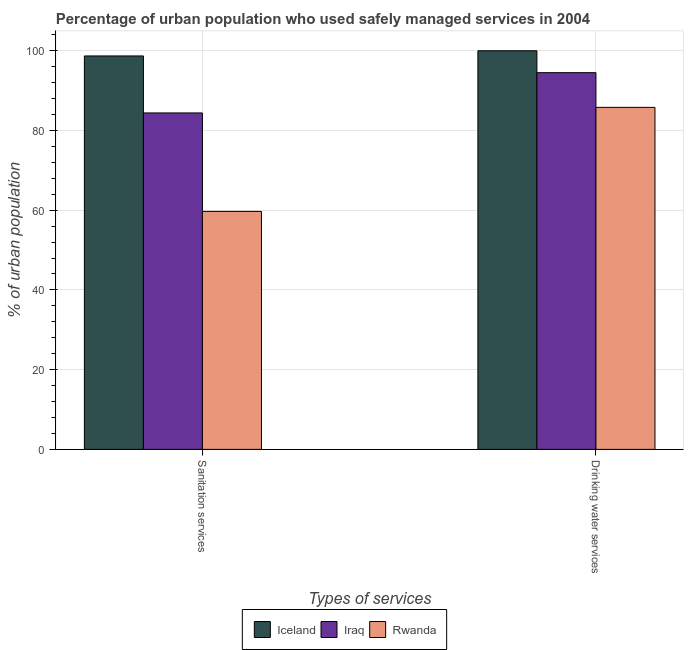How many different coloured bars are there?
Make the answer very short. 3. How many groups of bars are there?
Your response must be concise. 2. Are the number of bars per tick equal to the number of legend labels?
Offer a terse response. Yes. What is the label of the 1st group of bars from the left?
Ensure brevity in your answer.  Sanitation services. What is the percentage of urban population who used sanitation services in Iceland?
Keep it short and to the point. 98.7. Across all countries, what is the maximum percentage of urban population who used sanitation services?
Provide a short and direct response. 98.7. Across all countries, what is the minimum percentage of urban population who used sanitation services?
Offer a very short reply. 59.7. In which country was the percentage of urban population who used drinking water services maximum?
Give a very brief answer. Iceland. In which country was the percentage of urban population who used drinking water services minimum?
Offer a terse response. Rwanda. What is the total percentage of urban population who used sanitation services in the graph?
Offer a very short reply. 242.8. What is the difference between the percentage of urban population who used drinking water services in Iceland and that in Iraq?
Give a very brief answer. 5.5. What is the difference between the percentage of urban population who used sanitation services in Iraq and the percentage of urban population who used drinking water services in Iceland?
Provide a short and direct response. -15.6. What is the average percentage of urban population who used sanitation services per country?
Your response must be concise. 80.93. What is the difference between the percentage of urban population who used sanitation services and percentage of urban population who used drinking water services in Iceland?
Give a very brief answer. -1.3. In how many countries, is the percentage of urban population who used drinking water services greater than 24 %?
Give a very brief answer. 3. What is the ratio of the percentage of urban population who used sanitation services in Iceland to that in Iraq?
Provide a succinct answer. 1.17. Is the percentage of urban population who used sanitation services in Iraq less than that in Rwanda?
Your answer should be compact. No. What does the 2nd bar from the right in Drinking water services represents?
Offer a very short reply. Iraq. How many bars are there?
Offer a very short reply. 6. Are all the bars in the graph horizontal?
Ensure brevity in your answer.  No. Are the values on the major ticks of Y-axis written in scientific E-notation?
Offer a terse response. No. Does the graph contain any zero values?
Offer a terse response. No. Does the graph contain grids?
Provide a short and direct response. Yes. How are the legend labels stacked?
Give a very brief answer. Horizontal. What is the title of the graph?
Offer a terse response. Percentage of urban population who used safely managed services in 2004. Does "United States" appear as one of the legend labels in the graph?
Your answer should be compact. No. What is the label or title of the X-axis?
Offer a very short reply. Types of services. What is the label or title of the Y-axis?
Your answer should be compact. % of urban population. What is the % of urban population of Iceland in Sanitation services?
Provide a succinct answer. 98.7. What is the % of urban population of Iraq in Sanitation services?
Offer a very short reply. 84.4. What is the % of urban population of Rwanda in Sanitation services?
Provide a short and direct response. 59.7. What is the % of urban population of Iraq in Drinking water services?
Your answer should be compact. 94.5. What is the % of urban population of Rwanda in Drinking water services?
Your answer should be very brief. 85.8. Across all Types of services, what is the maximum % of urban population of Iraq?
Offer a very short reply. 94.5. Across all Types of services, what is the maximum % of urban population of Rwanda?
Keep it short and to the point. 85.8. Across all Types of services, what is the minimum % of urban population in Iceland?
Ensure brevity in your answer.  98.7. Across all Types of services, what is the minimum % of urban population of Iraq?
Your response must be concise. 84.4. Across all Types of services, what is the minimum % of urban population in Rwanda?
Offer a very short reply. 59.7. What is the total % of urban population in Iceland in the graph?
Provide a succinct answer. 198.7. What is the total % of urban population of Iraq in the graph?
Offer a very short reply. 178.9. What is the total % of urban population of Rwanda in the graph?
Your response must be concise. 145.5. What is the difference between the % of urban population in Iceland in Sanitation services and that in Drinking water services?
Give a very brief answer. -1.3. What is the difference between the % of urban population of Rwanda in Sanitation services and that in Drinking water services?
Your answer should be compact. -26.1. What is the average % of urban population of Iceland per Types of services?
Your answer should be very brief. 99.35. What is the average % of urban population of Iraq per Types of services?
Your answer should be compact. 89.45. What is the average % of urban population in Rwanda per Types of services?
Offer a very short reply. 72.75. What is the difference between the % of urban population of Iraq and % of urban population of Rwanda in Sanitation services?
Provide a short and direct response. 24.7. What is the difference between the % of urban population of Iceland and % of urban population of Iraq in Drinking water services?
Ensure brevity in your answer.  5.5. What is the difference between the % of urban population of Iceland and % of urban population of Rwanda in Drinking water services?
Your response must be concise. 14.2. What is the ratio of the % of urban population of Iceland in Sanitation services to that in Drinking water services?
Ensure brevity in your answer.  0.99. What is the ratio of the % of urban population of Iraq in Sanitation services to that in Drinking water services?
Provide a short and direct response. 0.89. What is the ratio of the % of urban population in Rwanda in Sanitation services to that in Drinking water services?
Provide a succinct answer. 0.7. What is the difference between the highest and the second highest % of urban population of Iceland?
Keep it short and to the point. 1.3. What is the difference between the highest and the second highest % of urban population in Rwanda?
Keep it short and to the point. 26.1. What is the difference between the highest and the lowest % of urban population of Iraq?
Keep it short and to the point. 10.1. What is the difference between the highest and the lowest % of urban population in Rwanda?
Keep it short and to the point. 26.1. 